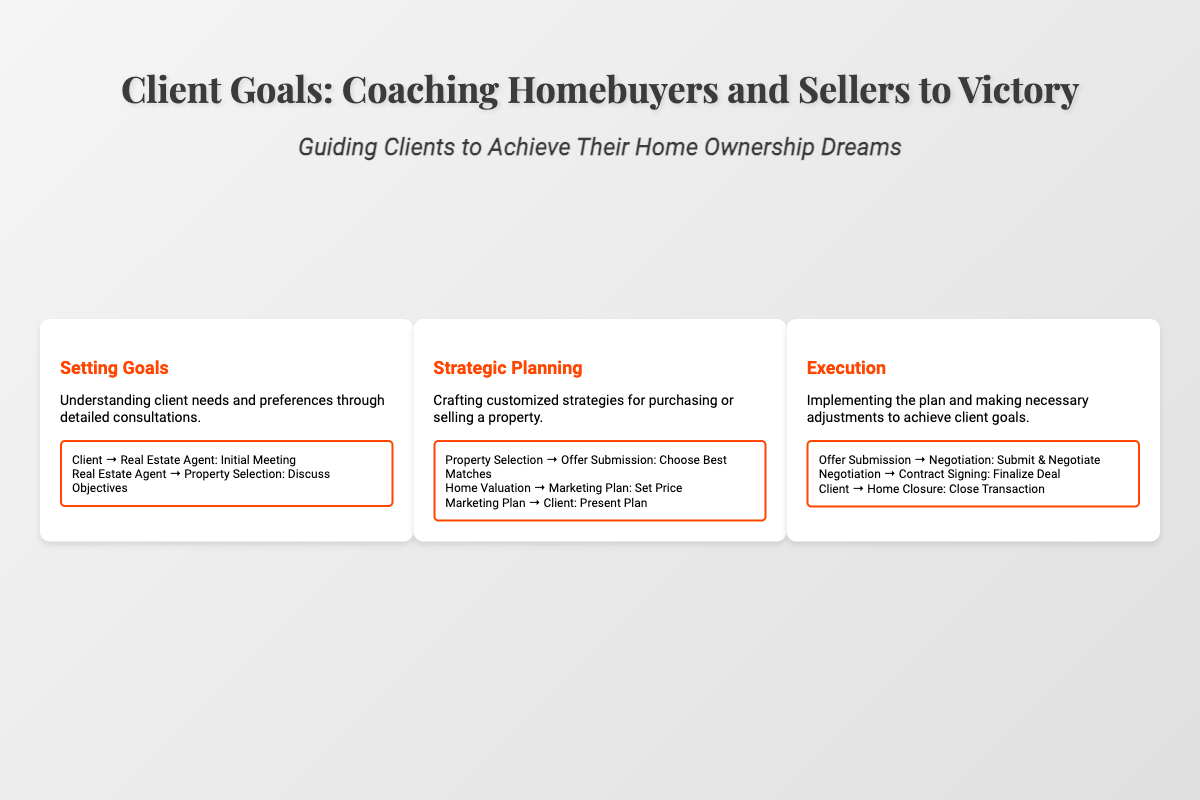What is the title of the book? The title of the book is prominently displayed at the top of the cover.
Answer: Client Goals: Coaching Homebuyers and Sellers to Victory What is the subtitle of the book? The subtitle provides additional context about the book's purpose, located below the title.
Answer: Guiding Clients to Achieve Their Home Ownership Dreams How many diagrams are on the cover? The cover features a total of three diagrams that outline different processes.
Answer: 3 What section discusses "Setting Goals"? "Setting Goals" is the title of the first diagram that describes understanding client needs.
Answer: Setting Goals What color is the watermark text? The color of the watermark text is specified to convey a subtle background design.
Answer: rgba(255,69,0,0.05) What is the primary theme of the diagrams? The diagrams are focused on the coaching process for homebuyers and sellers.
Answer: Coaching What type of icons are included at the bottom of the cover? The icons represent important concepts related to real estate transactions.
Answer: House, Contract, Key What is the background design pattern of the cover? The cover features a linear gradient background design that adds depth.
Answer: Linear gradient What does the diagonal structure of the playbook represent? The structure emphasizes a strategic game plan approach akin to sports playbooks.
Answer: Strategic planning 